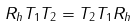<formula> <loc_0><loc_0><loc_500><loc_500>R _ { h } T _ { 1 } T _ { 2 } = T _ { 2 } T _ { 1 } R _ { h }</formula> 